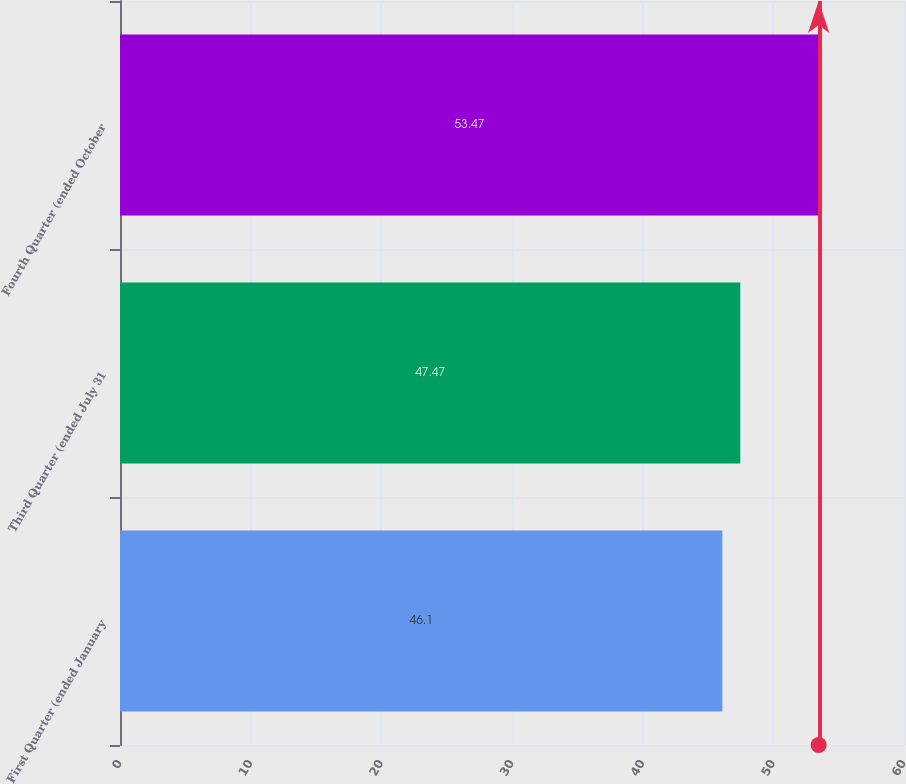Convert chart. <chart><loc_0><loc_0><loc_500><loc_500><bar_chart><fcel>First Quarter (ended January<fcel>Third Quarter (ended July 31<fcel>Fourth Quarter (ended October<nl><fcel>46.1<fcel>47.47<fcel>53.47<nl></chart> 